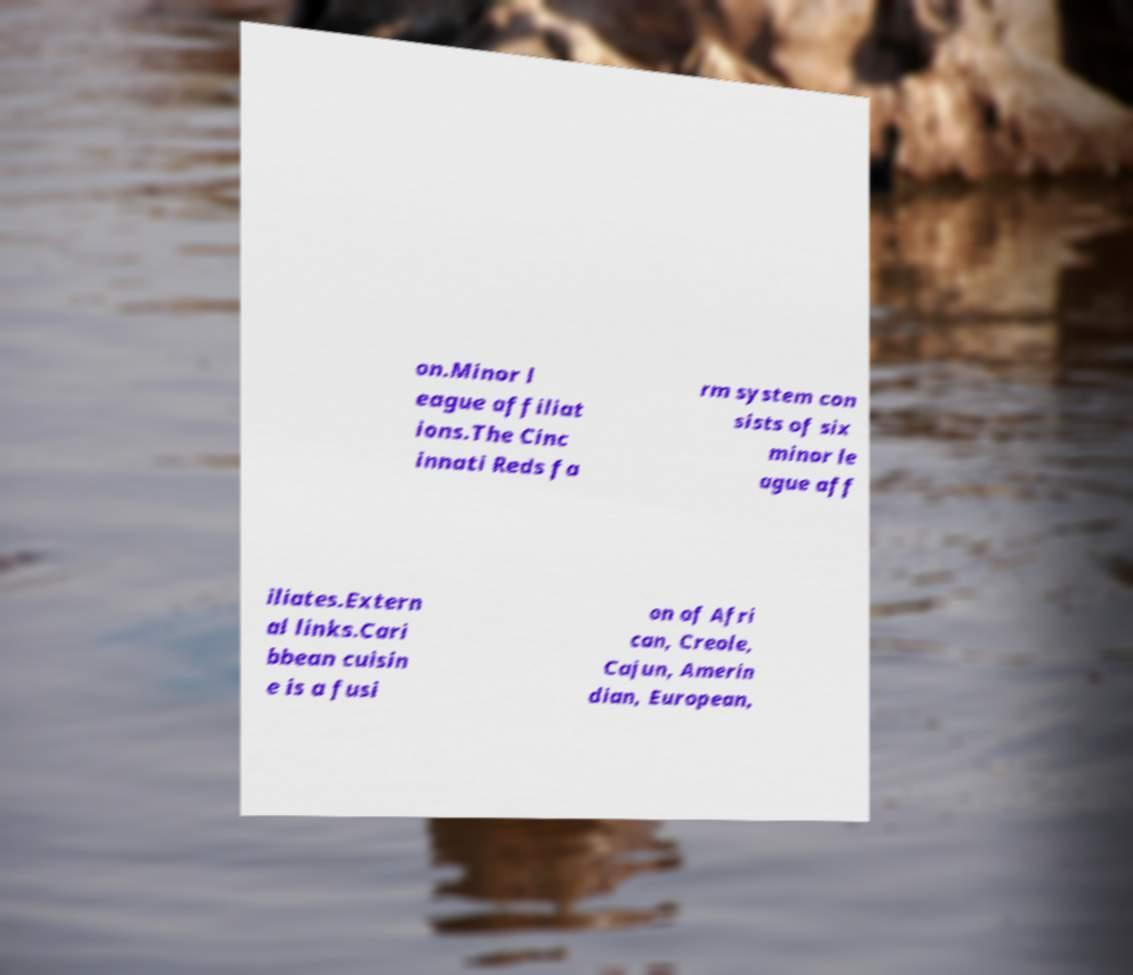Can you accurately transcribe the text from the provided image for me? on.Minor l eague affiliat ions.The Cinc innati Reds fa rm system con sists of six minor le ague aff iliates.Extern al links.Cari bbean cuisin e is a fusi on of Afri can, Creole, Cajun, Amerin dian, European, 